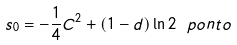<formula> <loc_0><loc_0><loc_500><loc_500>s _ { 0 } = - \frac { 1 } { 4 } C ^ { 2 } + ( 1 - d ) \ln 2 \ p o n t o</formula> 